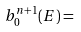<formula> <loc_0><loc_0><loc_500><loc_500>b ^ { n + 1 } _ { 0 } ( E ) =</formula> 